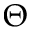<formula> <loc_0><loc_0><loc_500><loc_500>\Theta</formula> 